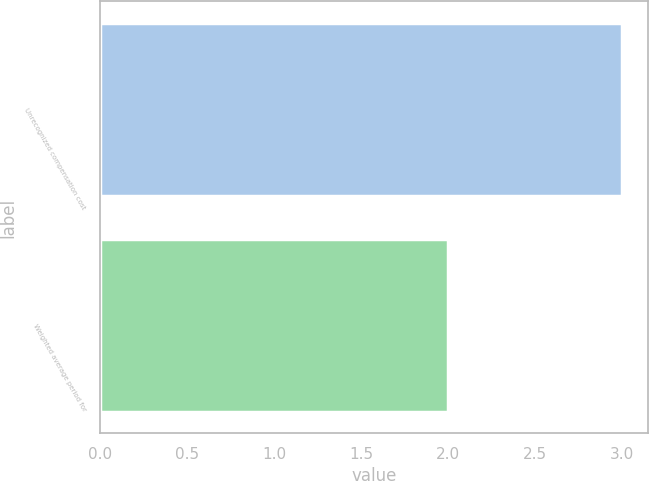Convert chart. <chart><loc_0><loc_0><loc_500><loc_500><bar_chart><fcel>Unrecognized compensation cost<fcel>Weighted average period for<nl><fcel>3<fcel>2<nl></chart> 